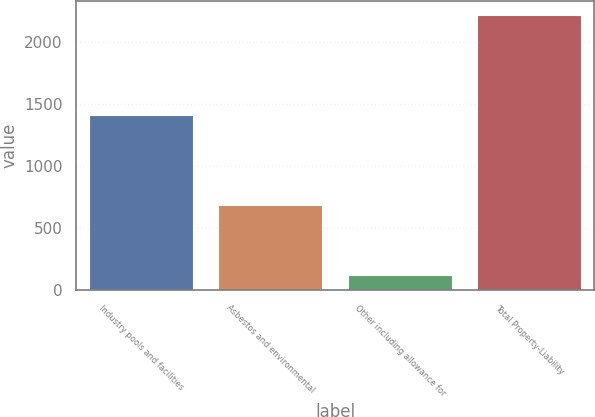Convert chart. <chart><loc_0><loc_0><loc_500><loc_500><bar_chart><fcel>Industry pools and facilities<fcel>Asbestos and environmental<fcel>Other including allowance for<fcel>Total Property-Liability<nl><fcel>1408<fcel>683<fcel>121<fcel>2212<nl></chart> 